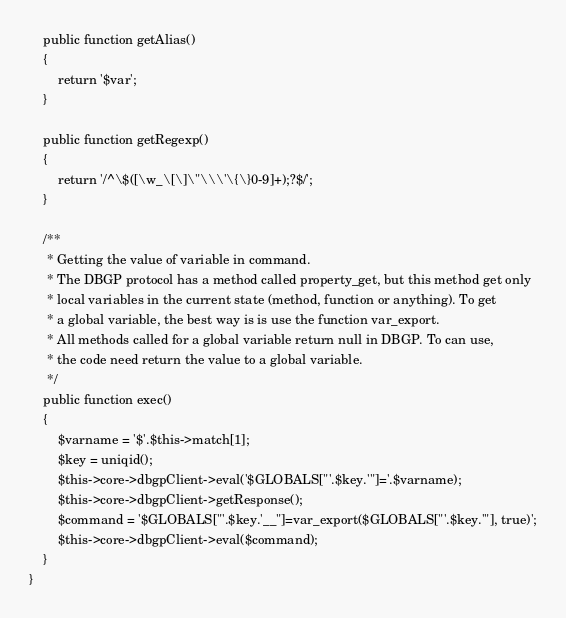Convert code to text. <code><loc_0><loc_0><loc_500><loc_500><_PHP_>
    public function getAlias()
    {
        return '$var';
    }

    public function getRegexp()
    {
        return '/^\$([\w_\[\]\"\\\'\{\}0-9]+);?$/';
    }

    /**
     * Getting the value of variable in command.
     * The DBGP protocol has a method called property_get, but this method get only
     * local variables in the current state (method, function or anything). To get
     * a global variable, the best way is is use the function var_export.
     * All methods called for a global variable return null in DBGP. To can use,
     * the code need return the value to a global variable.
     */
    public function exec()
    {
        $varname = '$'.$this->match[1];
        $key = uniqid();
        $this->core->dbgpClient->eval('$GLOBALS["'.$key.'"]='.$varname);
        $this->core->dbgpClient->getResponse();
        $command = '$GLOBALS["'.$key.'__"]=var_export($GLOBALS["'.$key.'"], true)';
        $this->core->dbgpClient->eval($command);
    }
}
</code> 